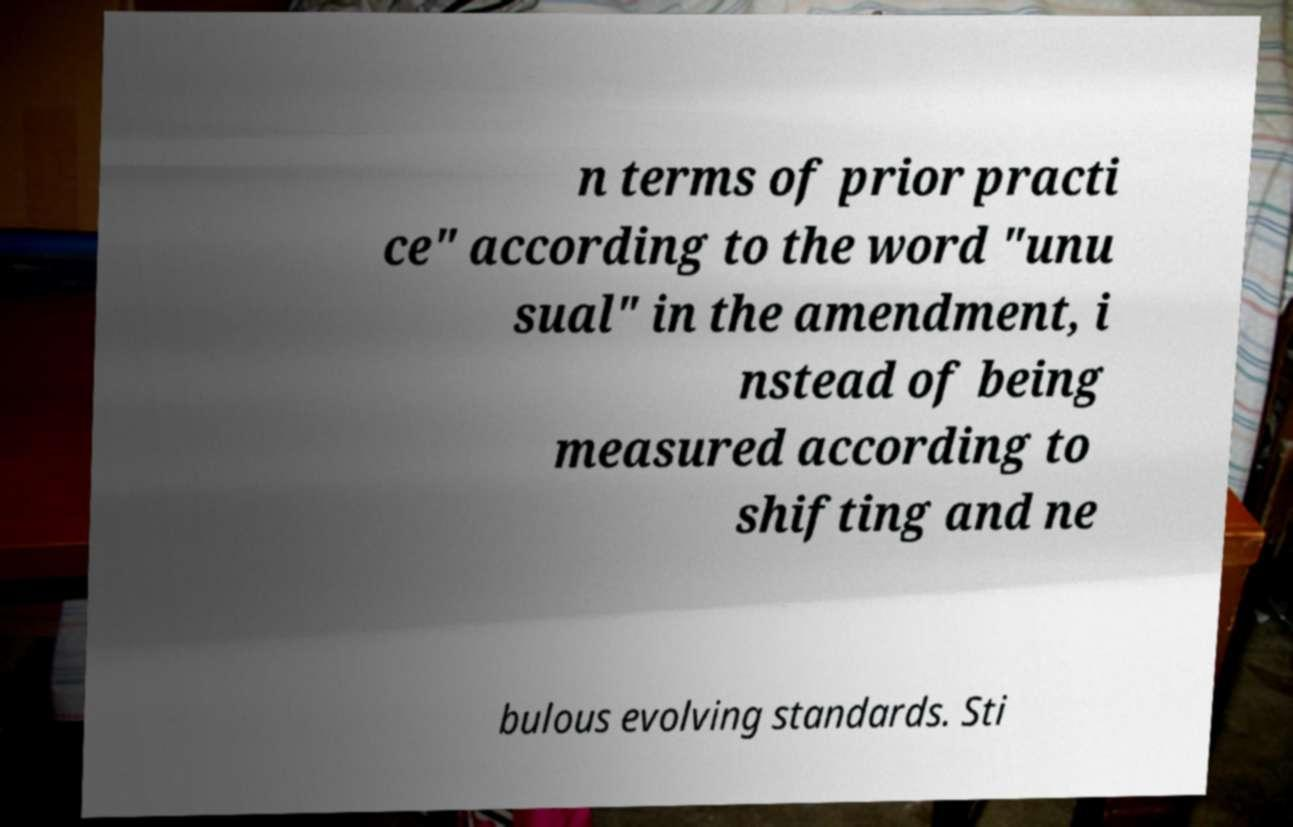Could you assist in decoding the text presented in this image and type it out clearly? n terms of prior practi ce" according to the word "unu sual" in the amendment, i nstead of being measured according to shifting and ne bulous evolving standards. Sti 